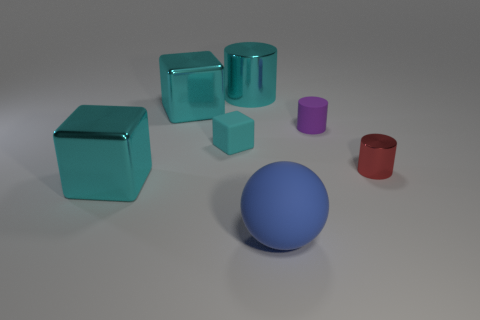What shapes are present in this image, and how could they relate to each other? The image features several geometric shapes: there are cylinders, cubes, and a sphere. These shapes can relate to each other in terms of spatial orientation, color coordination, and potential stacking or fitting interactions. For example, the cylinders and cubes could be stacked to create a structured arrangement, and the sphere could be placed atop a cylinder or enclosed within it. The color contrast and similarities also create a visual relationship between the objects. 